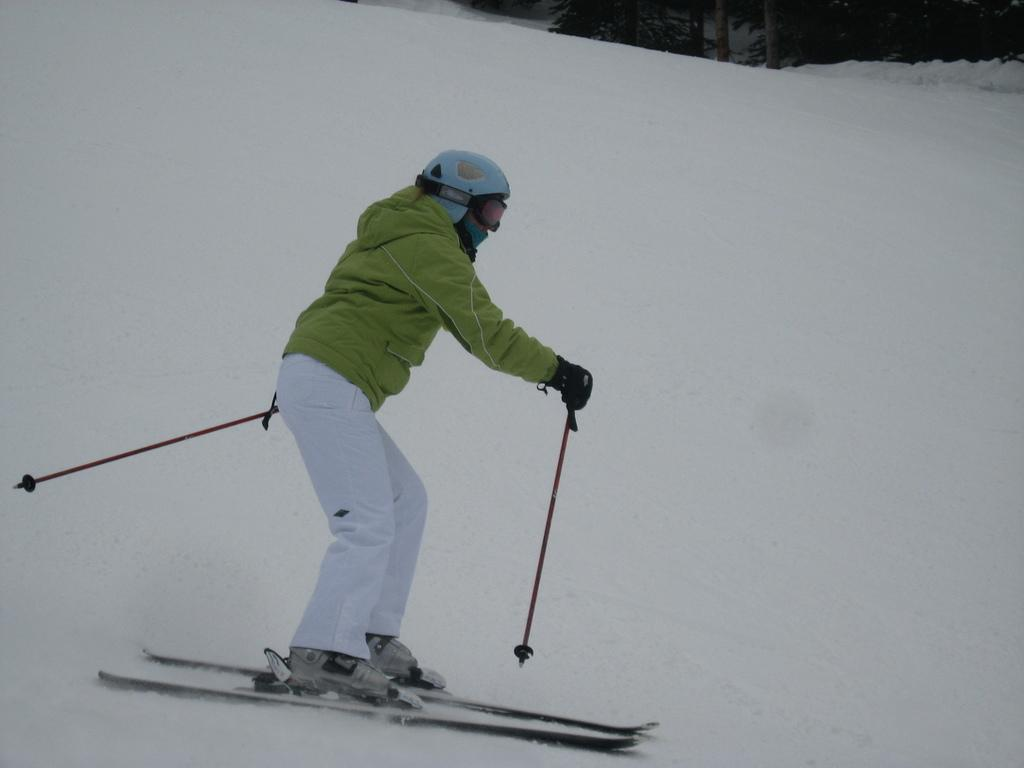What activity is the person in the image engaged in? There is a person skiing in the image. What type of terrain is visible in the image? There is snow in the image. What natural elements can be seen in the image? There are many trees in the image. What type of attack is being carried out by the brain in the image? There is no mention of an attack, brain, or burst in the image. 